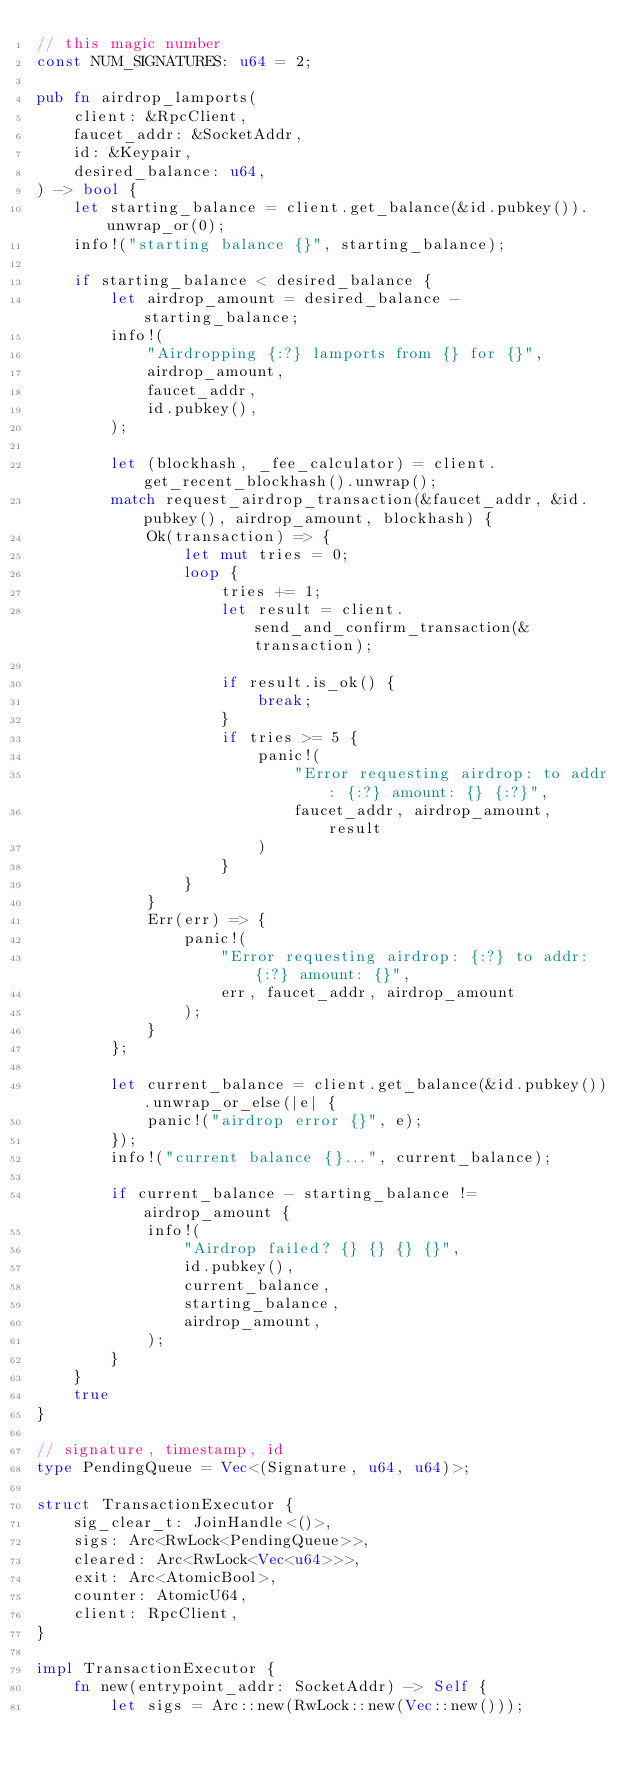Convert code to text. <code><loc_0><loc_0><loc_500><loc_500><_Rust_>// this magic number
const NUM_SIGNATURES: u64 = 2;

pub fn airdrop_lamports(
    client: &RpcClient,
    faucet_addr: &SocketAddr,
    id: &Keypair,
    desired_balance: u64,
) -> bool {
    let starting_balance = client.get_balance(&id.pubkey()).unwrap_or(0);
    info!("starting balance {}", starting_balance);

    if starting_balance < desired_balance {
        let airdrop_amount = desired_balance - starting_balance;
        info!(
            "Airdropping {:?} lamports from {} for {}",
            airdrop_amount,
            faucet_addr,
            id.pubkey(),
        );

        let (blockhash, _fee_calculator) = client.get_recent_blockhash().unwrap();
        match request_airdrop_transaction(&faucet_addr, &id.pubkey(), airdrop_amount, blockhash) {
            Ok(transaction) => {
                let mut tries = 0;
                loop {
                    tries += 1;
                    let result = client.send_and_confirm_transaction(&transaction);

                    if result.is_ok() {
                        break;
                    }
                    if tries >= 5 {
                        panic!(
                            "Error requesting airdrop: to addr: {:?} amount: {} {:?}",
                            faucet_addr, airdrop_amount, result
                        )
                    }
                }
            }
            Err(err) => {
                panic!(
                    "Error requesting airdrop: {:?} to addr: {:?} amount: {}",
                    err, faucet_addr, airdrop_amount
                );
            }
        };

        let current_balance = client.get_balance(&id.pubkey()).unwrap_or_else(|e| {
            panic!("airdrop error {}", e);
        });
        info!("current balance {}...", current_balance);

        if current_balance - starting_balance != airdrop_amount {
            info!(
                "Airdrop failed? {} {} {} {}",
                id.pubkey(),
                current_balance,
                starting_balance,
                airdrop_amount,
            );
        }
    }
    true
}

// signature, timestamp, id
type PendingQueue = Vec<(Signature, u64, u64)>;

struct TransactionExecutor {
    sig_clear_t: JoinHandle<()>,
    sigs: Arc<RwLock<PendingQueue>>,
    cleared: Arc<RwLock<Vec<u64>>>,
    exit: Arc<AtomicBool>,
    counter: AtomicU64,
    client: RpcClient,
}

impl TransactionExecutor {
    fn new(entrypoint_addr: SocketAddr) -> Self {
        let sigs = Arc::new(RwLock::new(Vec::new()));</code> 